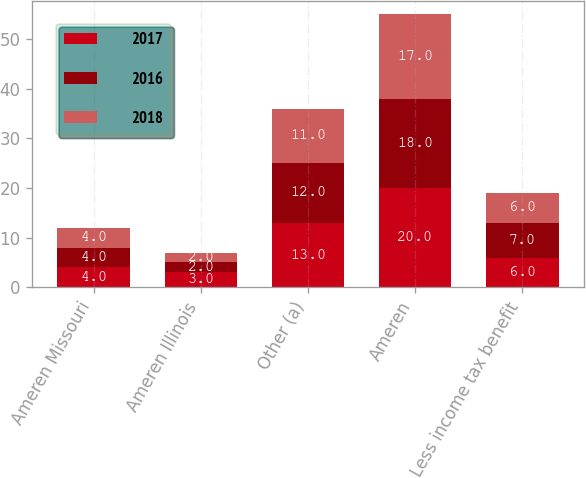Convert chart. <chart><loc_0><loc_0><loc_500><loc_500><stacked_bar_chart><ecel><fcel>Ameren Missouri<fcel>Ameren Illinois<fcel>Other (a)<fcel>Ameren<fcel>Less income tax benefit<nl><fcel>2017<fcel>4<fcel>3<fcel>13<fcel>20<fcel>6<nl><fcel>2016<fcel>4<fcel>2<fcel>12<fcel>18<fcel>7<nl><fcel>2018<fcel>4<fcel>2<fcel>11<fcel>17<fcel>6<nl></chart> 